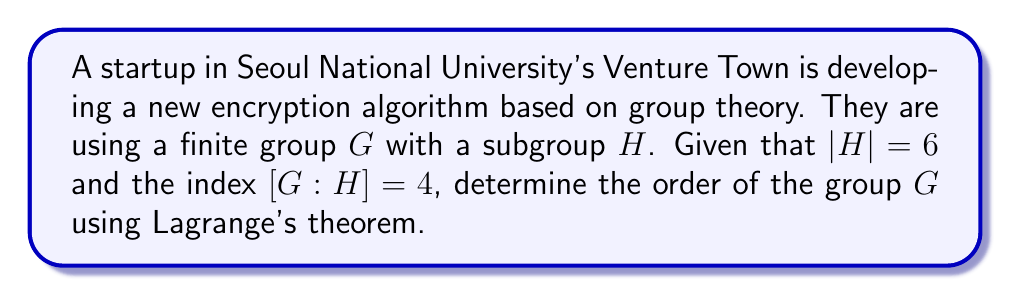Can you answer this question? To solve this problem, we'll use Lagrange's theorem and the given information about the subgroup and its index.

1) Lagrange's theorem states that for a finite group $G$ and a subgroup $H$ of $G$:

   $$|G| = |H| \cdot [G:H]$$

   where $|G|$ is the order of group $G$, $|H|$ is the order of subgroup $H$, and $[G:H]$ is the index of $H$ in $G$.

2) We are given:
   - $|H| = 6$
   - $[G:H] = 4$

3) Substituting these values into Lagrange's theorem:

   $$|G| = |H| \cdot [G:H] = 6 \cdot 4$$

4) Calculating the result:

   $$|G| = 24$$

Therefore, using Lagrange's theorem, we have determined that the order of the group $G$ is 24.
Answer: $|G| = 24$ 